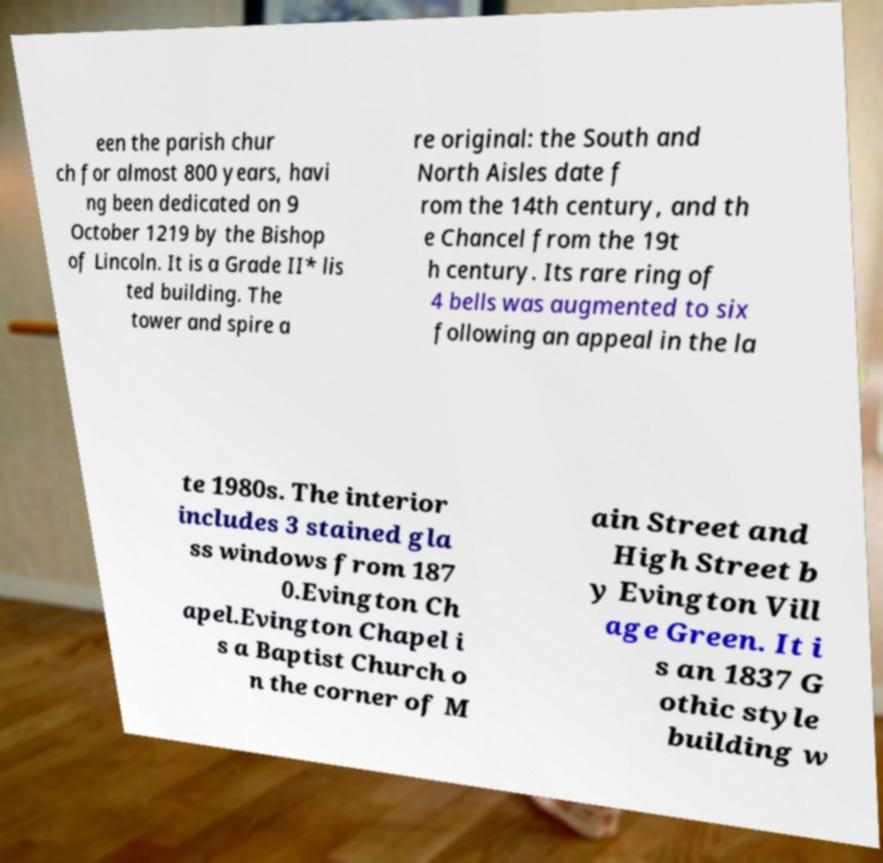Could you extract and type out the text from this image? een the parish chur ch for almost 800 years, havi ng been dedicated on 9 October 1219 by the Bishop of Lincoln. It is a Grade II* lis ted building. The tower and spire a re original: the South and North Aisles date f rom the 14th century, and th e Chancel from the 19t h century. Its rare ring of 4 bells was augmented to six following an appeal in the la te 1980s. The interior includes 3 stained gla ss windows from 187 0.Evington Ch apel.Evington Chapel i s a Baptist Church o n the corner of M ain Street and High Street b y Evington Vill age Green. It i s an 1837 G othic style building w 